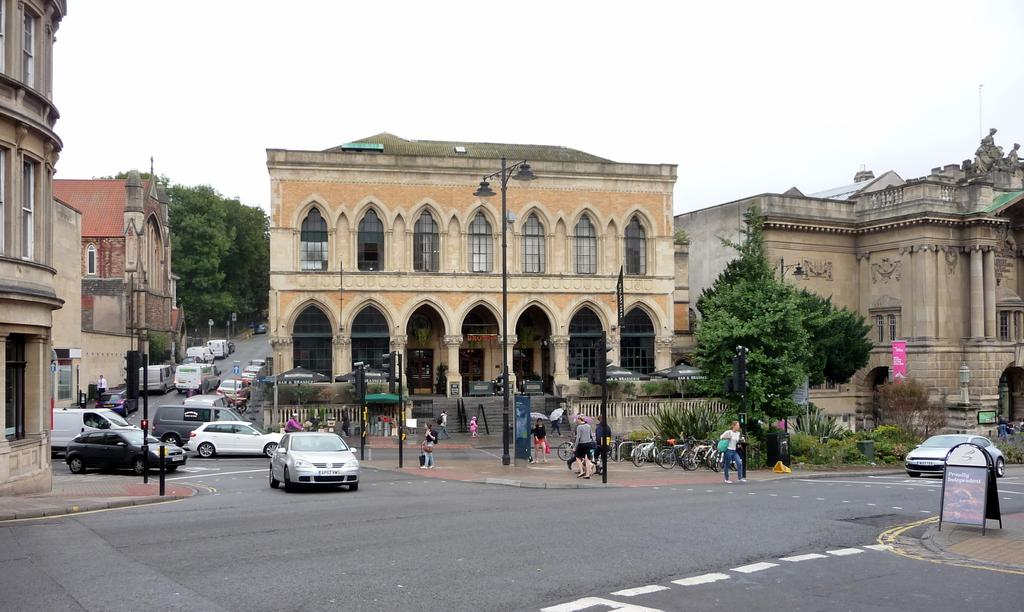What structures can be seen in the image? There are poles and buildings in the image. What types of transportation are visible in the image? There are vehicles in the image. Who or what is present in the image besides the structures and vehicles? There is a group of people in the image. What can be seen in the background of the image? There are trees, tents, hoardings, and bicycles in the background of the image. What type of wrist can be seen on the pole in the image? There is no wrist present on the pole in the image. What order is being followed by the group of people in the image? There is no specific order being followed by the group of people in the image. 